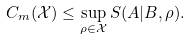Convert formula to latex. <formula><loc_0><loc_0><loc_500><loc_500>C _ { m } ( \mathcal { X } ) \leq \sup _ { \rho \in \mathcal { X } } S ( A | B , \rho ) .</formula> 